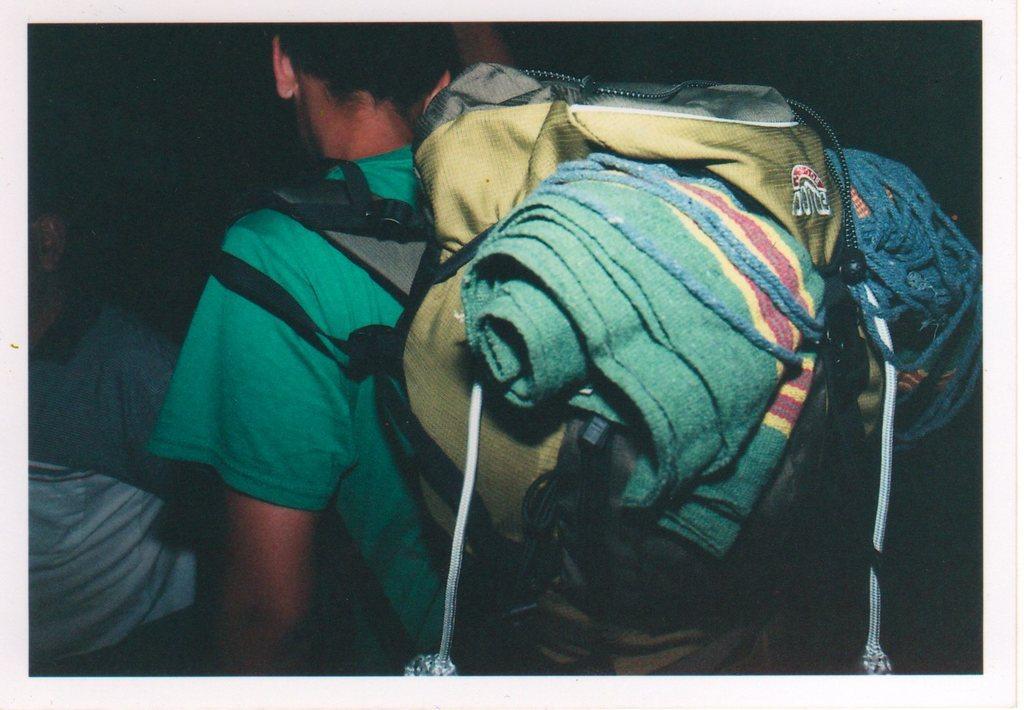How would you summarize this image in a sentence or two? In this image I can see a man and I can see he is carrying a bag, a green colour cloth and a rope. I can also see he is wearing a green colour t-shirt and on the left side of the image I can see one more person. I can also see this image is little bit in dark. 